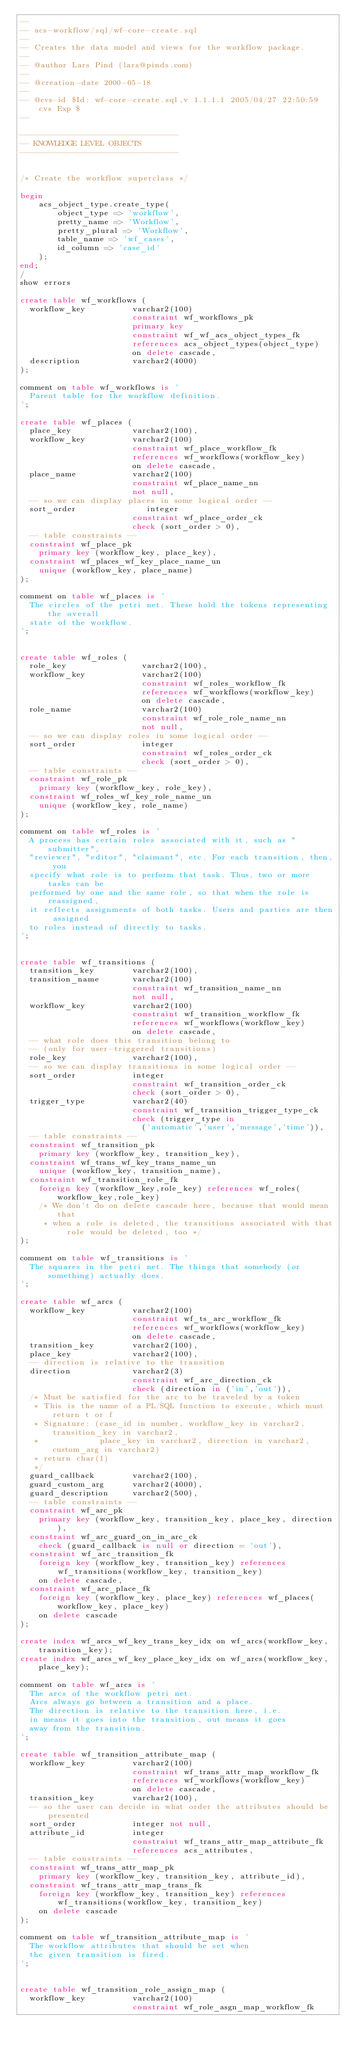Convert code to text. <code><loc_0><loc_0><loc_500><loc_500><_SQL_>--
-- acs-workflow/sql/wf-core-create.sql
--
-- Creates the data model and views for the workflow package.
--
-- @author Lars Pind (lars@pinds.com)
--
-- @creation-date 2000-05-18
--
-- @cvs-id $Id: wf-core-create.sql,v 1.1.1.1 2005/04/27 22:50:59 cvs Exp $
--

----------------------------------
-- KNOWLEDGE LEVEL OBJECTS
----------------------------------


/* Create the workflow superclass */

begin
    acs_object_type.create_type(
        object_type => 'workflow',
        pretty_name => 'Workflow',
        pretty_plural => 'Workflow',
        table_name => 'wf_cases',
        id_column => 'case_id'
    );  
end;
/
show errors

create table wf_workflows (
  workflow_key          varchar2(100)
                        constraint wf_workflows_pk
                        primary key
                        constraint wf_wf_acs_object_types_fk
                        references acs_object_types(object_type)
                        on delete cascade,
  description           varchar2(4000)
);

comment on table wf_workflows is '
  Parent table for the workflow definition.
';

create table wf_places (
  place_key             varchar2(100),
  workflow_key          varchar2(100)
                        constraint wf_place_workflow_fk
                        references wf_workflows(workflow_key)
                        on delete cascade,
  place_name            varchar2(100)
                        constraint wf_place_name_nn
                        not null,
  -- so we can display places in some logical order --
  sort_order               integer
                        constraint wf_place_order_ck
                        check (sort_order > 0),
  -- table constraints --
  constraint wf_place_pk
    primary key (workflow_key, place_key),
  constraint wf_places_wf_key_place_name_un
    unique (workflow_key, place_name)
);

comment on table wf_places is '
  The circles of the petri net. These hold the tokens representing the overall
  state of the workflow.
';


create table wf_roles (
  role_key                varchar2(100),
  workflow_key            varchar2(100)
                          constraint wf_roles_workflow_fk
                          references wf_workflows(workflow_key)
                          on delete cascade,
  role_name               varchar2(100)
                          constraint wf_role_role_name_nn
                          not null,
  -- so we can display roles in some logical order --
  sort_order              integer
                          constraint wf_roles_order_ck
                          check (sort_order > 0),
  -- table constraints --
  constraint wf_role_pk
    primary key (workflow_key, role_key),
  constraint wf_roles_wf_key_role_name_un
    unique (workflow_key, role_name)
);

comment on table wf_roles is '
  A process has certain roles associated with it, such as "submitter", 
  "reviewer", "editor", "claimant", etc. For each transition, then, you
  specify what role is to perform that task. Thus, two or more tasks can be
  performed by one and the same role, so that when the role is reassigned,
  it reflects assignments of both tasks. Users and parties are then assigned
  to roles instead of directly to tasks.
';


create table wf_transitions (
  transition_key        varchar2(100),
  transition_name       varchar2(100)
                        constraint wf_transition_name_nn
                        not null,
  workflow_key          varchar2(100)
                        constraint wf_transition_workflow_fk
                        references wf_workflows(workflow_key)
                        on delete cascade,
  -- what role does this transition belong to
  -- (only for user-triggered transitions)
  role_key              varchar2(100),
  -- so we can display transitions in some logical order --
  sort_order            integer
                        constraint wf_transition_order_ck
                        check (sort_order > 0),
  trigger_type          varchar2(40)
                        constraint wf_transition_trigger_type_ck
                        check (trigger_type in 
                          ('automatic','user','message','time')),
  -- table constraints --
  constraint wf_transition_pk
    primary key (workflow_key, transition_key),
  constraint wf_trans_wf_key_trans_name_un
    unique (workflow_key, transition_name),
  constraint wf_transition_role_fk
    foreign key (workflow_key,role_key) references wf_roles(workflow_key,role_key)
    /* We don't do on delete cascade here, because that would mean that 
     * when a role is deleted, the transitions associated with that role would be deleted, too */
);

comment on table wf_transitions is '
  The squares in the petri net. The things that somebody (or something) actually does.
';

create table wf_arcs (
  workflow_key          varchar2(100)
                        constraint wf_ts_arc_workflow_fk
                        references wf_workflows(workflow_key)
                        on delete cascade,
  transition_key        varchar2(100),
  place_key             varchar2(100),
  -- direction is relative to the transition
  direction             varchar2(3) 
                        constraint wf_arc_direction_ck
                        check (direction in ('in','out')),
  /* Must be satisfied for the arc to be traveled by a token
   * This is the name of a PL/SQL function to execute, which must return t or f
   * Signature: (case_id in number, workflow_key in varchar2, transition_key in varchar2, 
   *             place_key in varchar2, direction in varchar2, custom_arg in varchar2) 
   * return char(1)
   */
  guard_callback        varchar2(100),
  guard_custom_arg      varchar2(4000),
  guard_description     varchar2(500),
  -- table constraints -- 
  constraint wf_arc_pk
    primary key (workflow_key, transition_key, place_key, direction),
  constraint wf_arc_guard_on_in_arc_ck
    check (guard_callback is null or direction = 'out'),
  constraint wf_arc_transition_fk
    foreign key (workflow_key, transition_key) references wf_transitions(workflow_key, transition_key)
    on delete cascade,
  constraint wf_arc_place_fk
    foreign key (workflow_key, place_key) references wf_places(workflow_key, place_key)
    on delete cascade
);

create index wf_arcs_wf_key_trans_key_idx on wf_arcs(workflow_key, transition_key);
create index wf_arcs_wf_key_place_key_idx on wf_arcs(workflow_key, place_key);

comment on table wf_arcs is '
  The arcs of the workflow petri net.
  Arcs always go between a transition and a place.
  The direction is relative to the transition here, i.e.
  in means it goes into the transition, out means it goes
  away from the transition.
';

create table wf_transition_attribute_map (
  workflow_key          varchar2(100)
                        constraint wf_trans_attr_map_workflow_fk
                        references wf_workflows(workflow_key)
                        on delete cascade,
  transition_key        varchar2(100),
  -- so the user can decide in what order the attributes should be presented
  sort_order            integer not null,
  attribute_id          integer
                        constraint wf_trans_attr_map_attribute_fk
                        references acs_attributes,
  -- table constraints --
  constraint wf_trans_attr_map_pk
    primary key (workflow_key, transition_key, attribute_id),
  constraint wf_trans_attr_map_trans_fk
    foreign key (workflow_key, transition_key) references wf_transitions(workflow_key, transition_key)
    on delete cascade
);

comment on table wf_transition_attribute_map is '
  The workflow attributes that should be set when
  the given transition is fired.
';


create table wf_transition_role_assign_map (
  workflow_key          varchar2(100)
                        constraint wf_role_asgn_map_workflow_fk</code> 